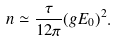<formula> <loc_0><loc_0><loc_500><loc_500>n \simeq \frac { \tau } { 1 2 \pi } ( g E _ { 0 } ) ^ { 2 } .</formula> 